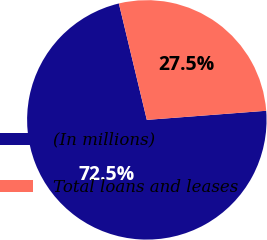<chart> <loc_0><loc_0><loc_500><loc_500><pie_chart><fcel>(In millions)<fcel>Total loans and leases<nl><fcel>72.46%<fcel>27.54%<nl></chart> 